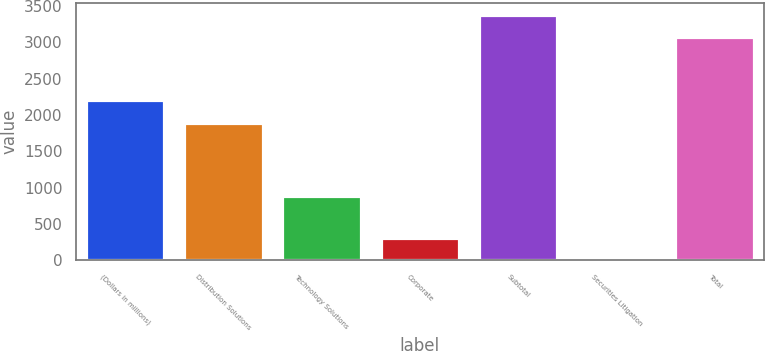Convert chart to OTSL. <chart><loc_0><loc_0><loc_500><loc_500><bar_chart><fcel>(Dollars in millions)<fcel>Distribution Solutions<fcel>Technology Solutions<fcel>Corporate<fcel>Subtotal<fcel>Securities Litigation<fcel>Total<nl><fcel>2202.8<fcel>1896<fcel>884<fcel>312.8<fcel>3374.8<fcel>6<fcel>3068<nl></chart> 